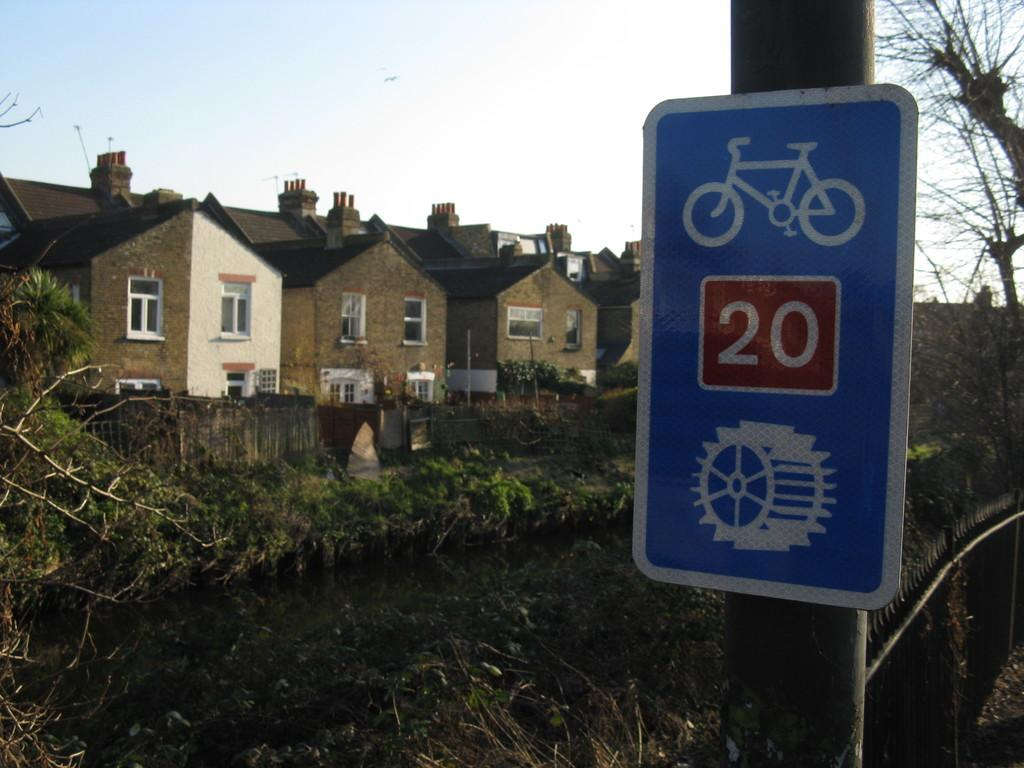Provide a one-sentence caption for the provided image. A sign that is blue and has a number 20 in a red box. 